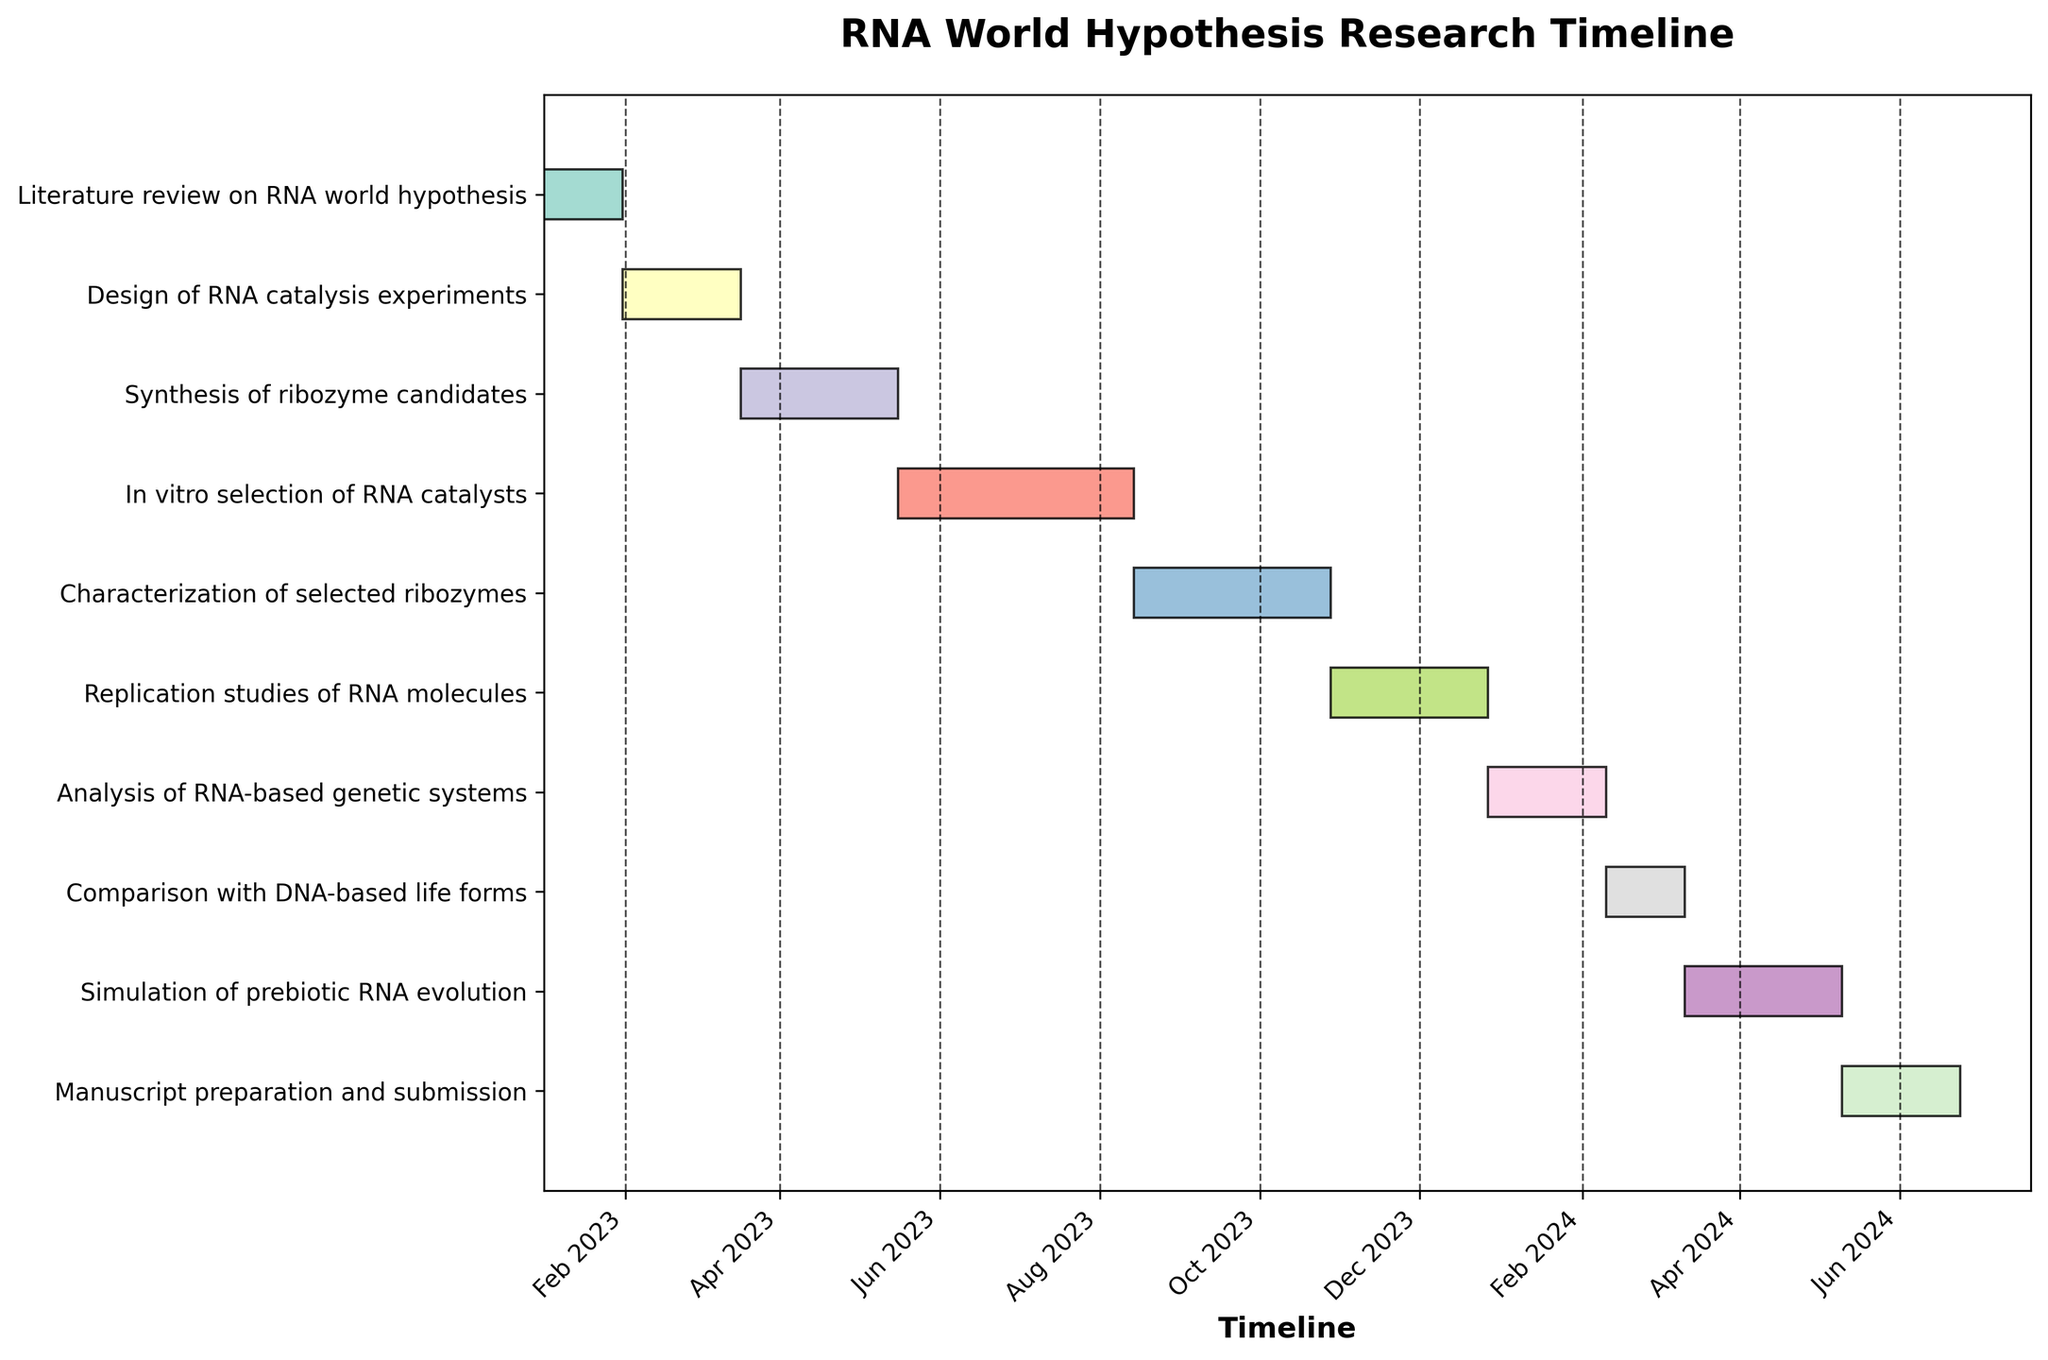Which task lasts the longest? To determine the task with the longest duration, compare all the given durations. The task with the duration of 90 days is "In vitro selection of RNA catalysts".
Answer: In vitro selection of RNA catalysts When was the literature review on RNA world hypothesis completed? The task "Literature review on RNA world hypothesis" starts on 2023-01-01 and lasts for 30 days. Adding 30 days to January 1, 2023, the completion date is January 31, 2023.
Answer: January 31, 2023 How many tasks overlap with the "Synthesis of ribozyme candidates"? "Synthesis of ribozyme candidates" starts on 2023-03-17 and lasts for 60 days, ending on 2023-05-16. The overlapping tasks are those that either start before 2023-05-16 and end after 2023-03-17 or fall completely within this period. These tasks are "Design of RNA catalysis experiments" and "In vitro selection of RNA catalysts".
Answer: 2 Which task starts immediately after "Characterization of selected ribozymes"? "Characterization of selected ribozymes" ends after 75 days from 2023-08-14, which is October 28, 2023. The task that starts on this date is "Replication studies of RNA molecules".
Answer: Replication studies of RNA molecules What is the total duration from the start of the first task to the end of the last task? The first task starts on 2023-01-01, and the last task ends 45 days after 2024-05-10, i.e., on 2024-06-24. The total duration is from January 1, 2023, to June 24, 2024. This duration includes 1 year and almost 6 months.
Answer: ~1.5 years Which two tasks have the closest starting dates? To find the closest starting dates, compute the difference between the start dates of all adjacent tasks. "Literature review on RNA world hypothesis" ends on 2023-01-31, and "Design of RNA catalysis experiments" starts on the same day, thus these two tasks have the closest starting dates.
Answer: Literature review on RNA world hypothesis and Design of RNA catalysis experiments What is the shortest task, and how long does it last? To find the shortest task, identify the one with the minimum duration. "Literature review on RNA world hypothesis" with a duration of 30 days is the shortest task.
Answer: Literature review on RNA world hypothesis, 30 days How do the durations of tasks related to RNA molecule mechanisms compare to those related to simulation and manuscript preparation? The tasks related to RNA molecule mechanisms are "Synthesis of ribozyme candidates" (60 days), "In vitro selection of RNA catalysts" (90 days), "Characterization of selected ribozymes" (75 days), and "Replication studies of RNA molecules" (60 days). The tasks related to simulation and manuscript preparation are "Simulation of prebiotic RNA evolution" (60 days) and "Manuscript preparation and submission" (45 days). Summing up, mechanisms = 60 + 90 + 75 + 60 = 285 days; simulation and preparation = 60 + 45 = 105 days. RNA molecule mechanism tasks are considerably longer.
Answer: RNA molecule mechanisms tasks last 285 days, while simulation and manuscript preparation tasks last 105 days 